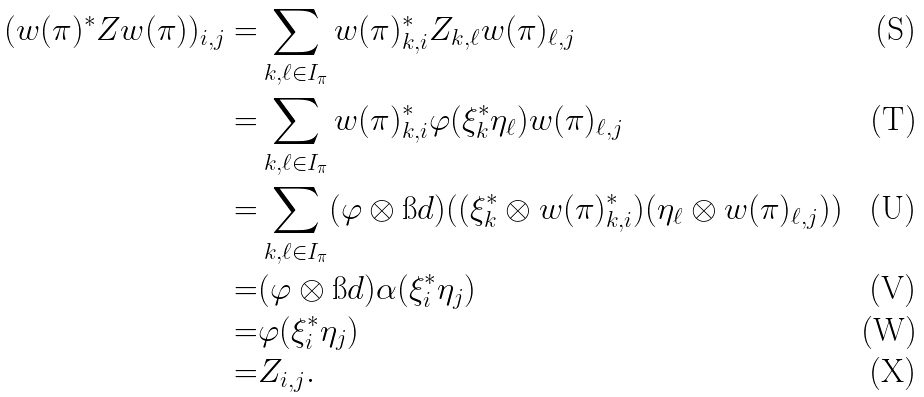Convert formula to latex. <formula><loc_0><loc_0><loc_500><loc_500>( w ( \pi ) ^ { * } Z w ( \pi ) ) _ { i , j } = & \sum _ { k , \ell \in I _ { \pi } } w ( \pi ) _ { k , i } ^ { * } Z _ { k , \ell } w ( \pi ) _ { \ell , j } \\ = & \sum _ { k , \ell \in I _ { \pi } } w ( \pi ) _ { k , i } ^ { * } \varphi ( \xi _ { k } ^ { * } \eta _ { \ell } ) w ( \pi ) _ { \ell , j } \\ = & \sum _ { k , \ell \in I _ { \pi } } ( \varphi \otimes \i d ) ( ( \xi _ { k } ^ { * } \otimes w ( \pi ) _ { k , i } ^ { * } ) ( \eta _ { \ell } \otimes w ( \pi ) _ { \ell , j } ) ) \\ = & ( \varphi \otimes \i d ) \alpha ( \xi _ { i } ^ { * } \eta _ { j } ) \\ = & \varphi ( \xi _ { i } ^ { * } \eta _ { j } ) \\ = & Z _ { i , j } .</formula> 